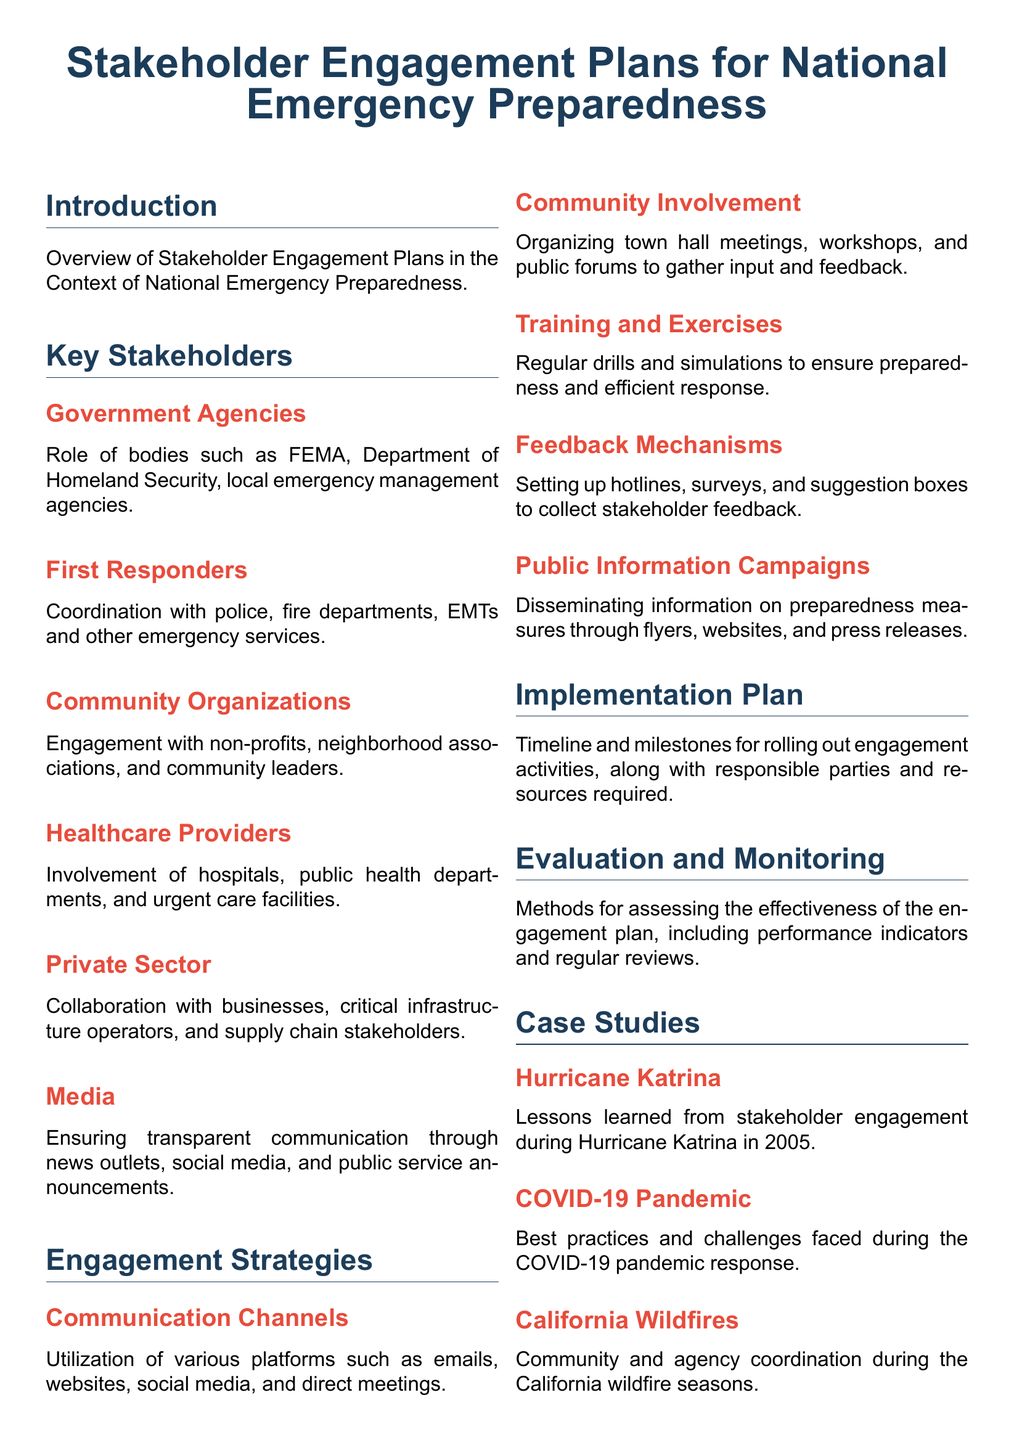What is the title of the document? The title is provided at the top of the document, defining the main focus on stakeholder engagement plans related to emergency preparedness.
Answer: Stakeholder Engagement Plans for National Emergency Preparedness Which agency is responsible for emergency management? The document lists FEMA and other local agencies as key stakeholders involved in national emergency preparedness.
Answer: FEMA What role do healthcare providers play? The document specifies that healthcare providers include hospitals and public health departments that are involved in emergency preparedness.
Answer: Involvement What type of meetings are organized for community involvement? Town hall meetings are mentioned as a method of engaging the community to gather feedback in the document.
Answer: Town hall meetings What natural disaster is used as a case study? The document includes Hurricane Katrina as a key example of stakeholder engagement during an emergency response scenario.
Answer: Hurricane Katrina What is the color used for section headings? The primary color used for section headings is defined in the document format and is noted.
Answer: Primary color How often should training and exercises be conducted? The document suggests regular drills for preparedness, emphasizing the routine nature of these activities for stakeholders.
Answer: Regularly What does the evaluation section assess? The evaluation section focuses on assessing effectiveness through performance indicators and includes methods for regular reviews.
Answer: Effectiveness What is one method for collecting stakeholder feedback? The document lists hotlines as one of the mechanisms established for collecting feedback from stakeholders during engagement.
Answer: Hotlines 